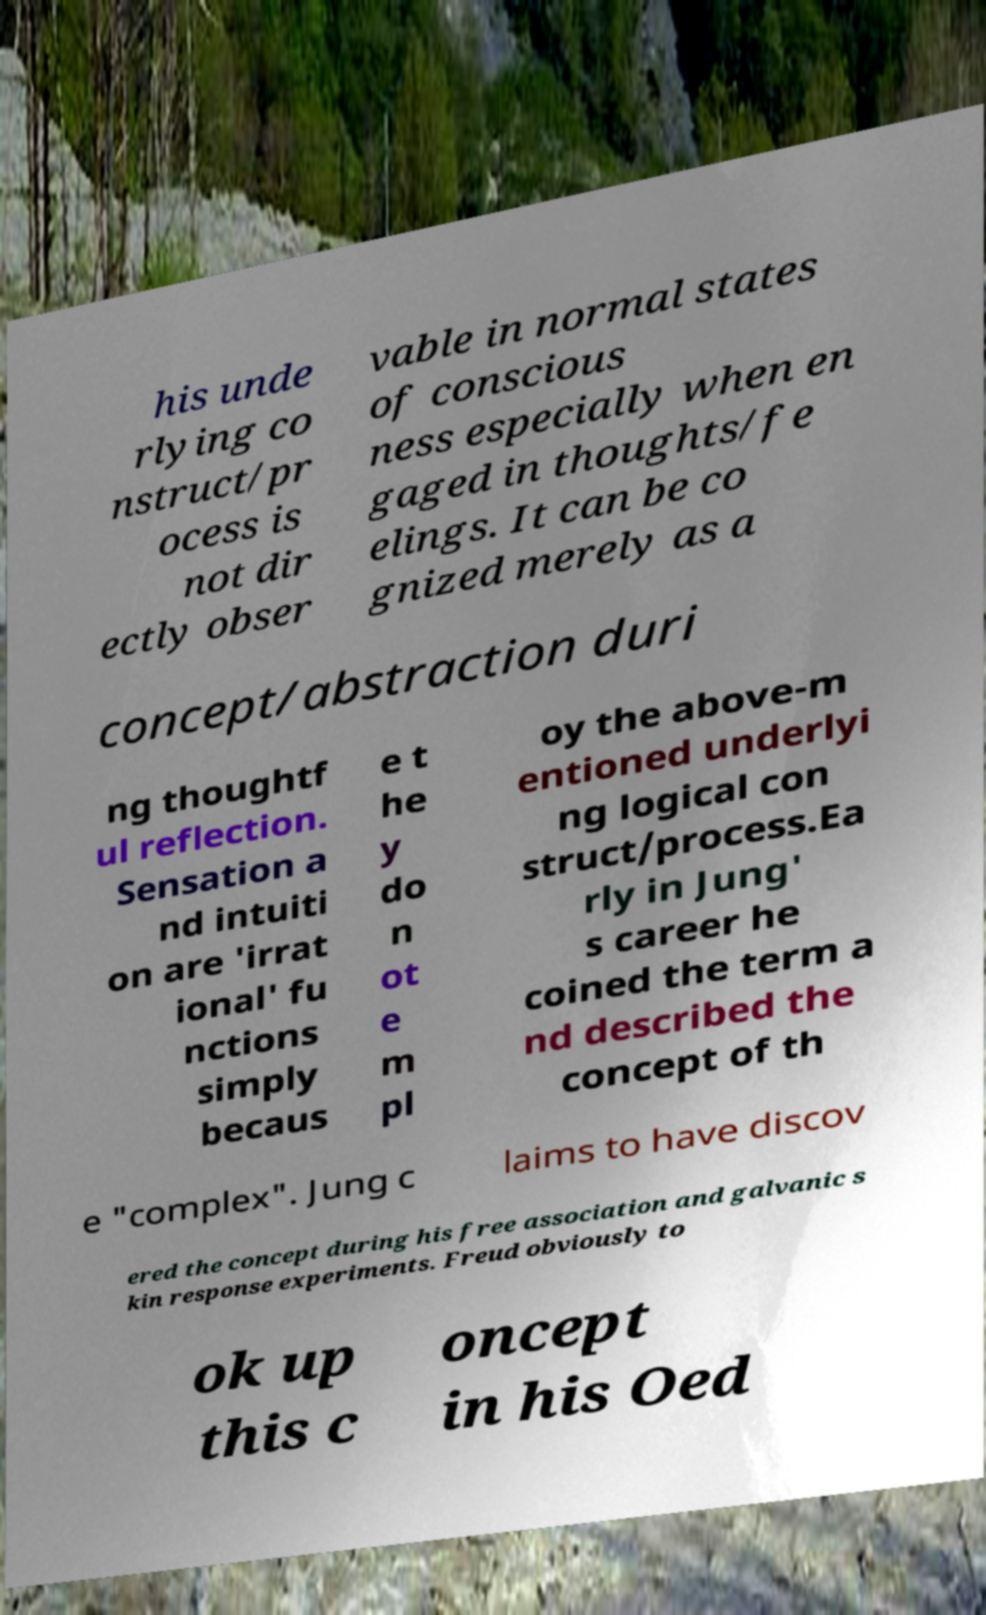Please identify and transcribe the text found in this image. his unde rlying co nstruct/pr ocess is not dir ectly obser vable in normal states of conscious ness especially when en gaged in thoughts/fe elings. It can be co gnized merely as a concept/abstraction duri ng thoughtf ul reflection. Sensation a nd intuiti on are 'irrat ional' fu nctions simply becaus e t he y do n ot e m pl oy the above-m entioned underlyi ng logical con struct/process.Ea rly in Jung' s career he coined the term a nd described the concept of th e "complex". Jung c laims to have discov ered the concept during his free association and galvanic s kin response experiments. Freud obviously to ok up this c oncept in his Oed 